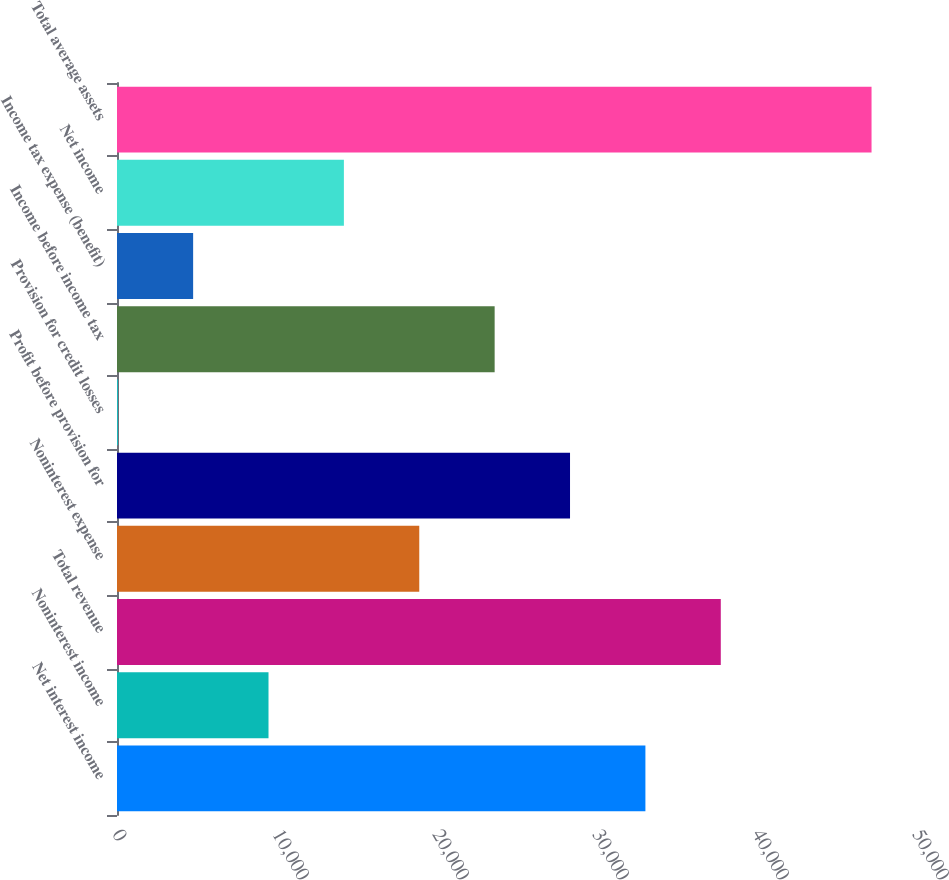<chart> <loc_0><loc_0><loc_500><loc_500><bar_chart><fcel>Net interest income<fcel>Noninterest income<fcel>Total revenue<fcel>Noninterest expense<fcel>Profit before provision for<fcel>Provision for credit losses<fcel>Income before income tax<fcel>Income tax expense (benefit)<fcel>Net income<fcel>Total average assets<nl><fcel>33025.4<fcel>9469.4<fcel>37736.6<fcel>18891.8<fcel>28314.2<fcel>47<fcel>23603<fcel>4758.2<fcel>14180.6<fcel>47159<nl></chart> 